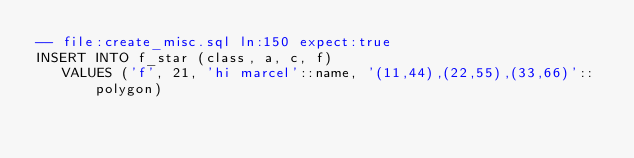<code> <loc_0><loc_0><loc_500><loc_500><_SQL_>-- file:create_misc.sql ln:150 expect:true
INSERT INTO f_star (class, a, c, f)
   VALUES ('f', 21, 'hi marcel'::name, '(11,44),(22,55),(33,66)'::polygon)
</code> 